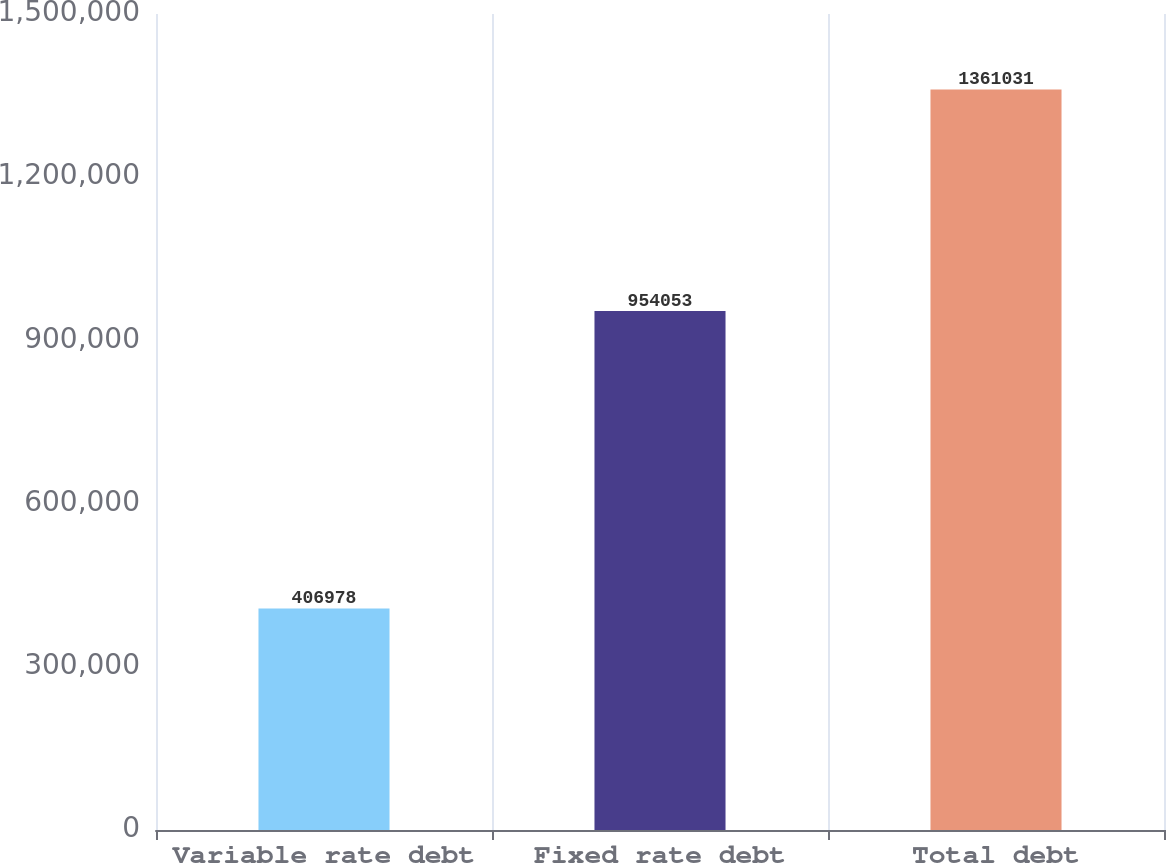Convert chart. <chart><loc_0><loc_0><loc_500><loc_500><bar_chart><fcel>Variable rate debt<fcel>Fixed rate debt<fcel>Total debt<nl><fcel>406978<fcel>954053<fcel>1.36103e+06<nl></chart> 